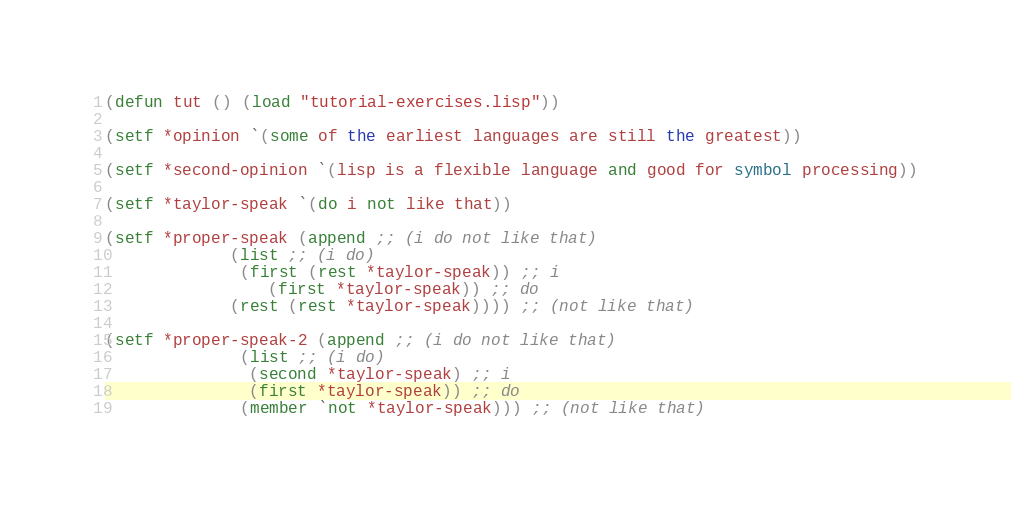<code> <loc_0><loc_0><loc_500><loc_500><_Lisp_>(defun tut () (load "tutorial-exercises.lisp"))

(setf *opinion `(some of the earliest languages are still the greatest))

(setf *second-opinion `(lisp is a flexible language and good for symbol processing))

(setf *taylor-speak `(do i not like that))

(setf *proper-speak (append ;; (i do not like that)
		     (list ;; (i do)
		      (first (rest *taylor-speak)) ;; i
			     (first *taylor-speak)) ;; do
		     (rest (rest *taylor-speak)))) ;; (not like that)

(setf *proper-speak-2 (append ;; (i do not like that)
		      (list ;; (i do)
		       (second *taylor-speak) ;; i
		       (first *taylor-speak)) ;; do
		      (member `not *taylor-speak))) ;; (not like that)
</code> 